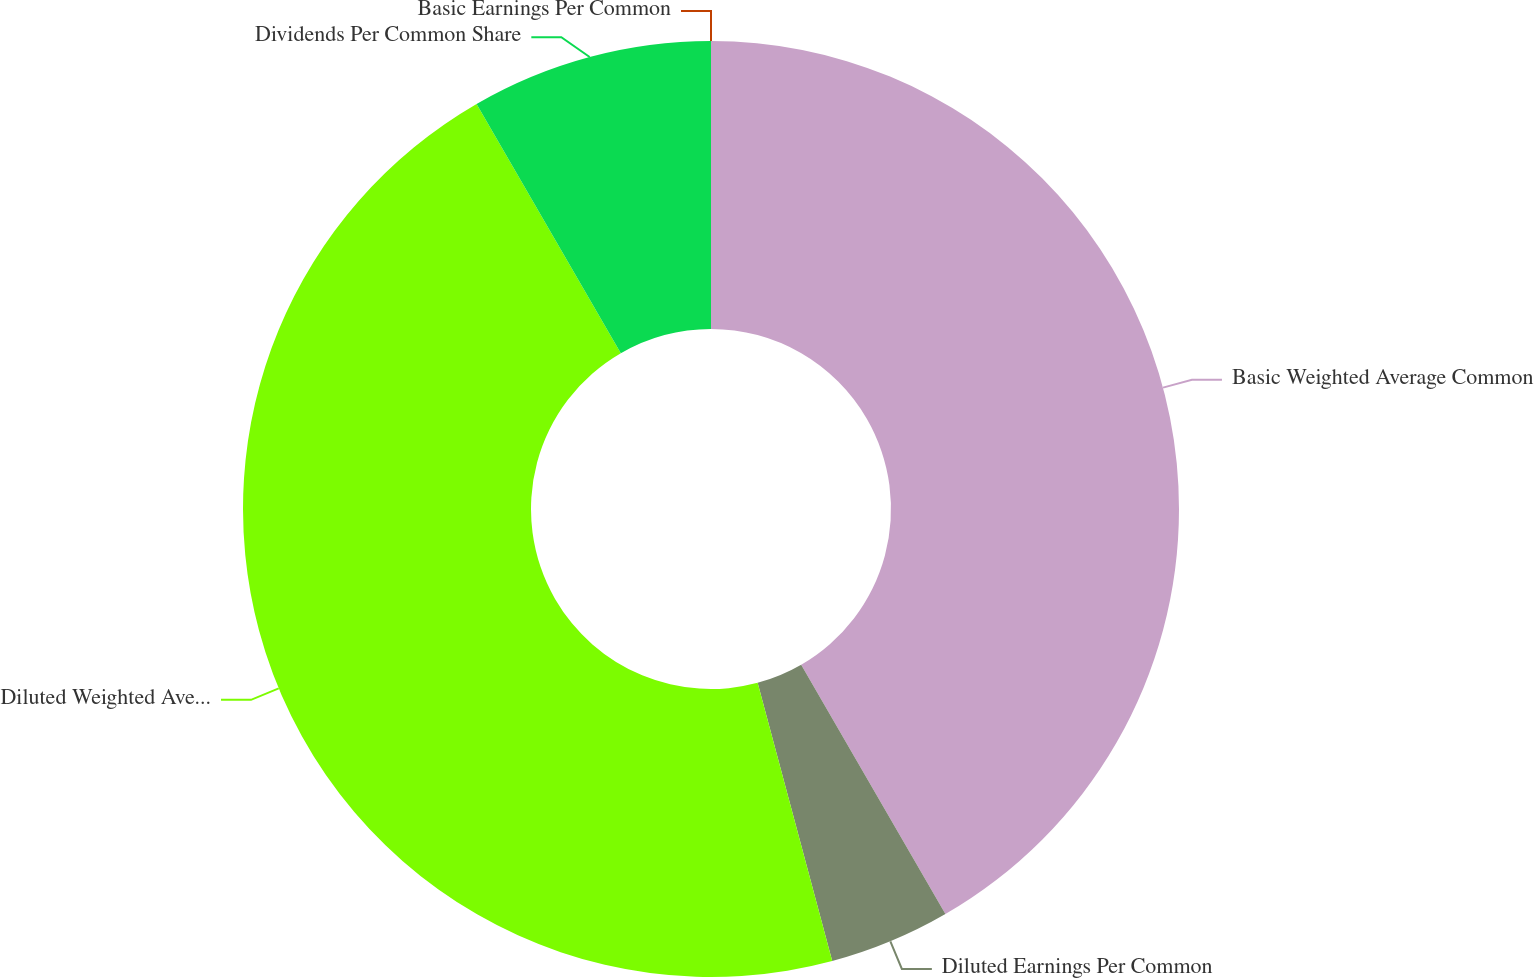Convert chart to OTSL. <chart><loc_0><loc_0><loc_500><loc_500><pie_chart><fcel>Basic Earnings Per Common<fcel>Basic Weighted Average Common<fcel>Diluted Earnings Per Common<fcel>Diluted Weighted Average<fcel>Dividends Per Common Share<nl><fcel>0.0%<fcel>41.65%<fcel>4.18%<fcel>45.82%<fcel>8.35%<nl></chart> 